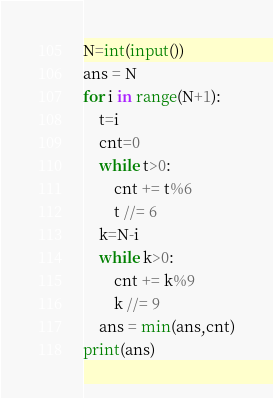Convert code to text. <code><loc_0><loc_0><loc_500><loc_500><_Python_>N=int(input())
ans = N
for i in range(N+1):
    t=i
    cnt=0
    while t>0:
        cnt += t%6
        t //= 6
    k=N-i
    while k>0:
        cnt += k%9
        k //= 9
    ans = min(ans,cnt)
print(ans)</code> 